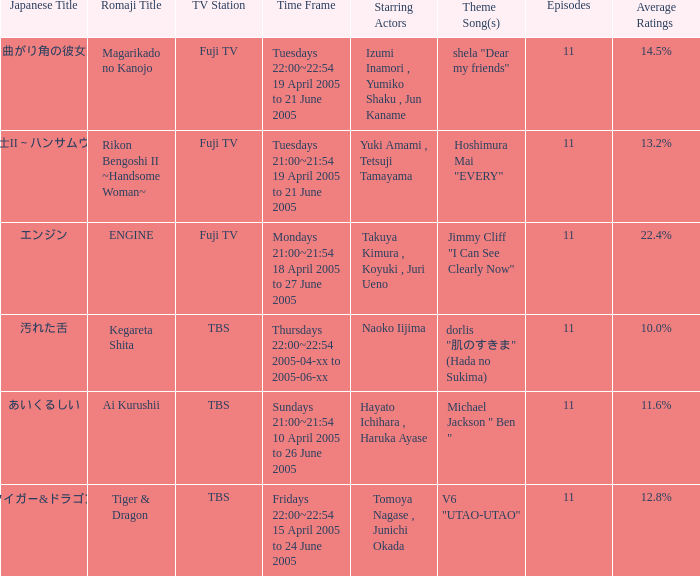What is the title with an average rating of 22.4%? ENGINE. 